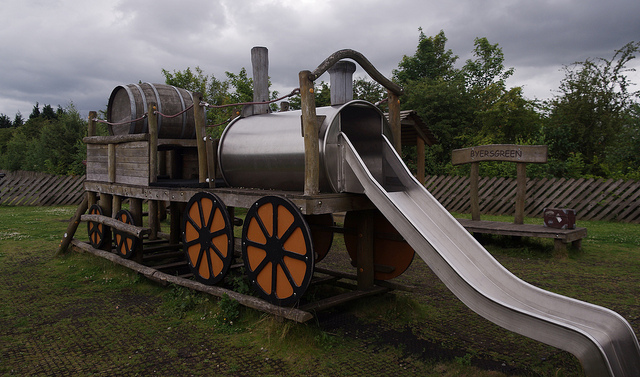Please identify all text content in this image. BYERSGREEN 